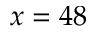<formula> <loc_0><loc_0><loc_500><loc_500>x = 4 8</formula> 